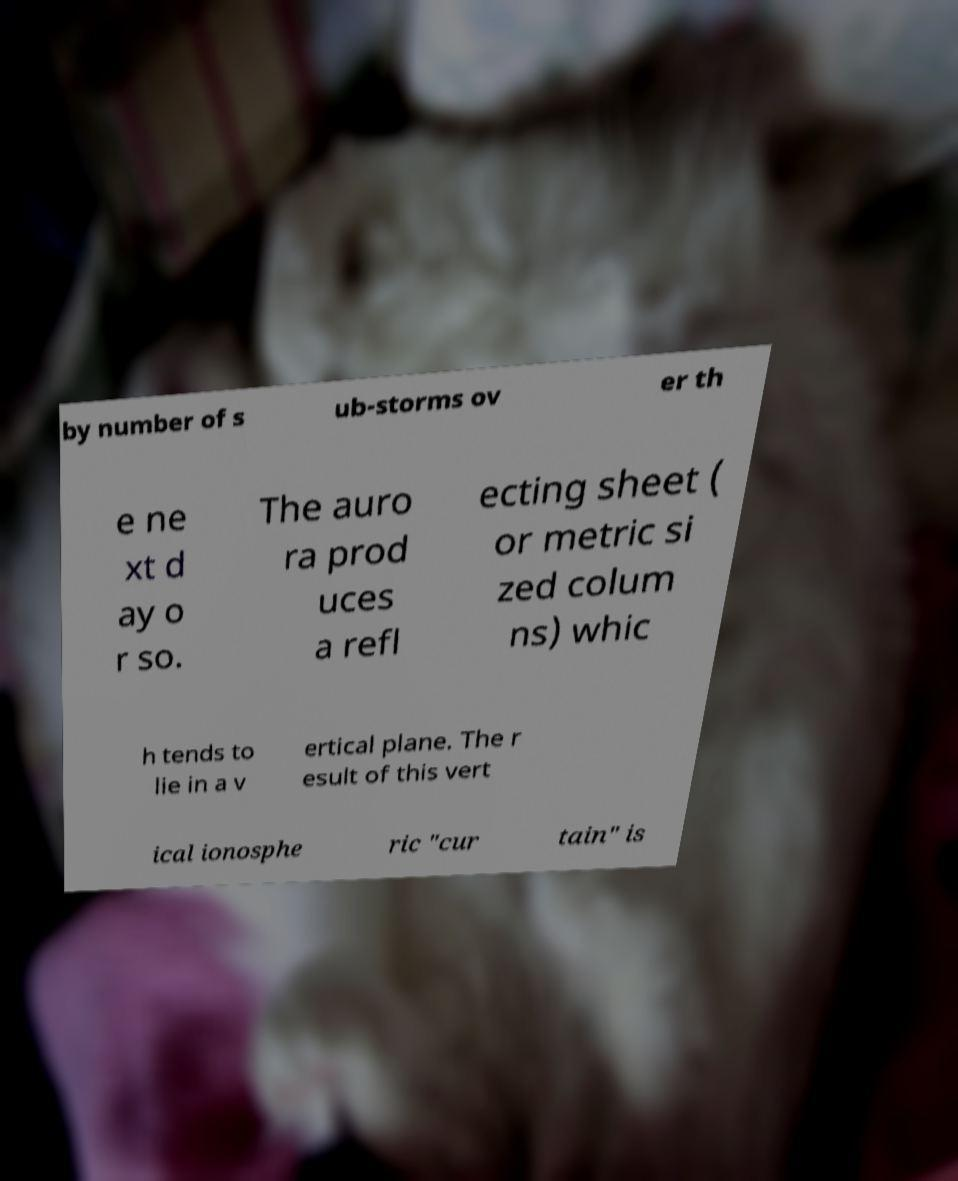Could you extract and type out the text from this image? by number of s ub-storms ov er th e ne xt d ay o r so. The auro ra prod uces a refl ecting sheet ( or metric si zed colum ns) whic h tends to lie in a v ertical plane. The r esult of this vert ical ionosphe ric "cur tain" is 